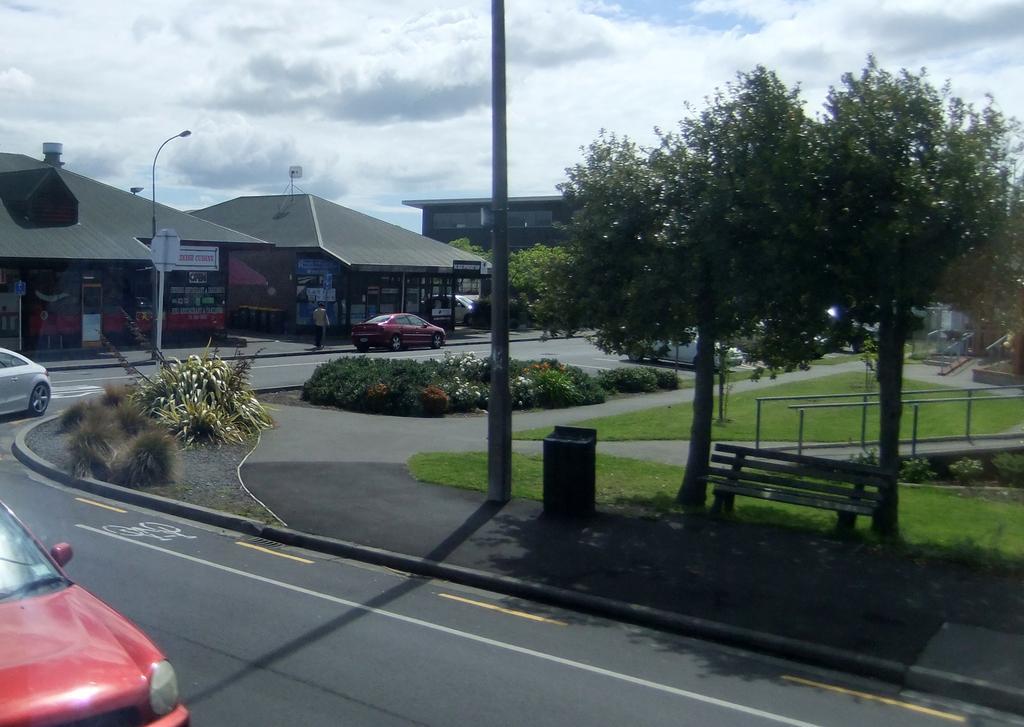In one or two sentences, can you explain what this image depicts? In this image we can see buildings, street poles, street lights, sign boards, persons standing on the road, motor vehicles, bushes, trash bins, benches, walkway bridge, trees and sky with clouds. 